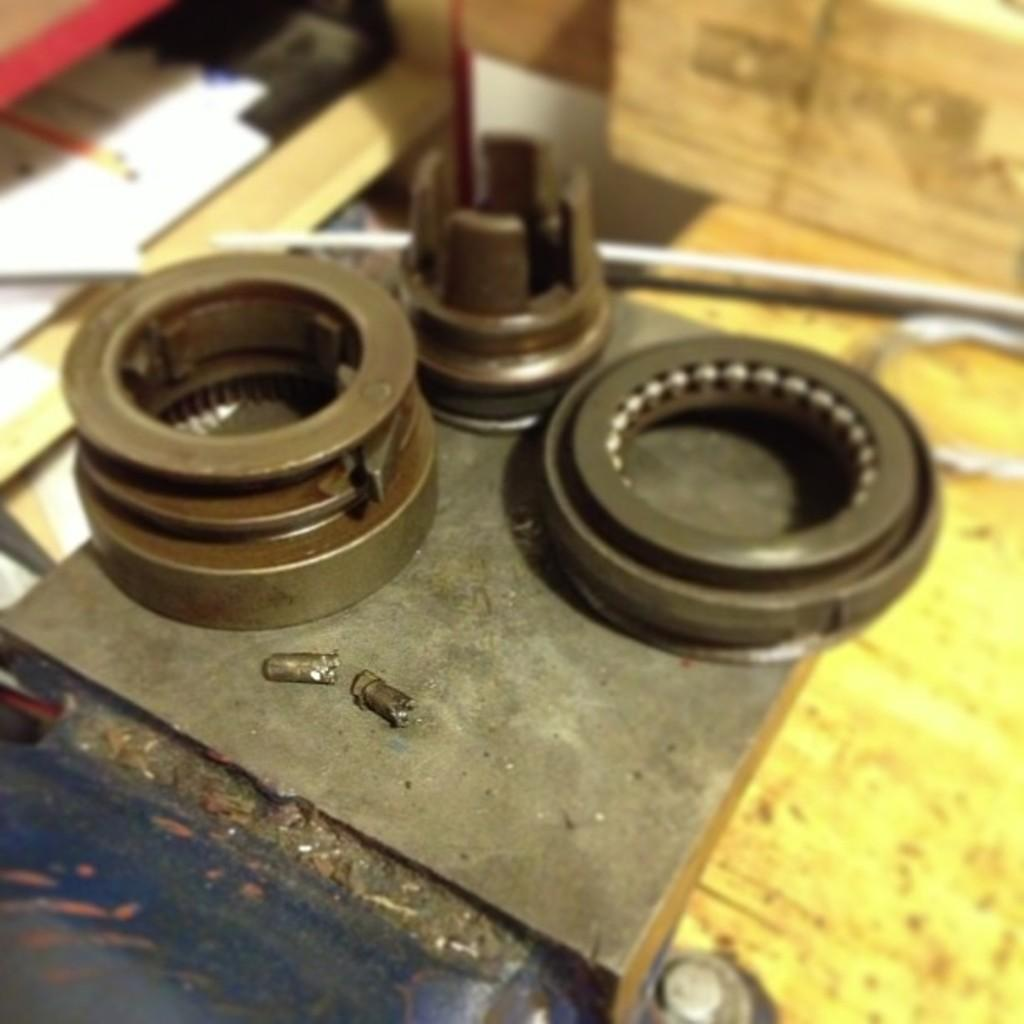What type of material is the object in the image made of? The object in the image is made of metal. Where is the metal object located in the image? The metal object is on a surface in the image. What else can be seen in the image besides the metal object? There are papers in the image. How are the papers positioned in relation to the metal object? The papers are beside the metal object in the image. What type of meal is being prepared on the metal object in the image? There is no meal being prepared on the metal object in the image; it is simply a metal object on a surface with papers beside it. 